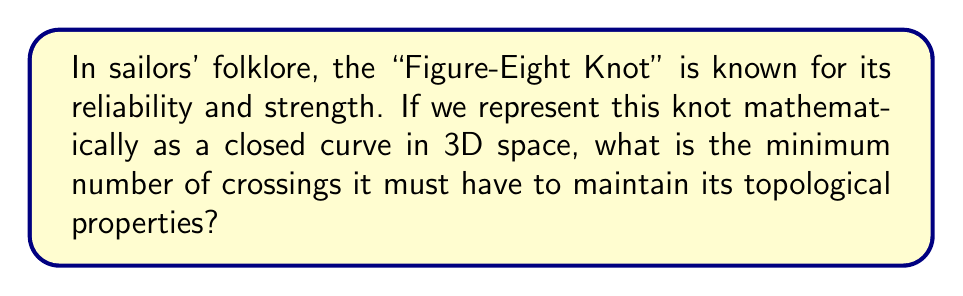What is the answer to this math problem? To answer this question, let's break it down into steps:

1. Understanding the Figure-Eight Knot:
   The Figure-Eight Knot, also known as the Flemish Knot, is one of the simplest non-trivial knots in mathematics.

2. Defining Crossings:
   In knot theory, a crossing is a point where the knot passes over or under itself when projected onto a 2D plane.

3. Minimal Crossing Number:
   The minimal crossing number of a knot is the least number of crossings that occur in any projection of the knot.

4. Properties of the Figure-Eight Knot:
   - It is classified as a prime knot, meaning it cannot be decomposed into simpler knots.
   - It is amphichiral, which means it is equivalent to its mirror image.

5. Mathematical Representation:
   In knot theory, we can represent the Figure-Eight Knot using a knot diagram:

   [asy]
   import geometry;

   path p = (0,0)..(1,1)..(2,0)..(1,-1)..(0,0);
   path q = (0.5,0.5)..(1.5,-0.5)..(0.5,-0.5)..(1.5,0.5)..(0.5,0.5);

   draw(p,linewidth(1));
   draw(q,linewidth(1));

   dot((0,0));
   dot((2,0));
   dot((1,1));
   dot((1,-1));
   [/asy]

6. Counting Crossings:
   In this standard representation, we can clearly see that the Figure-Eight Knot has exactly 4 crossings.

7. Proof of Minimality:
   It can be mathematically proven that it's impossible to represent the Figure-Eight Knot with fewer than 4 crossings while maintaining its topological properties.

Therefore, the minimum number of crossings for the Figure-Eight Knot is 4.
Answer: 4 